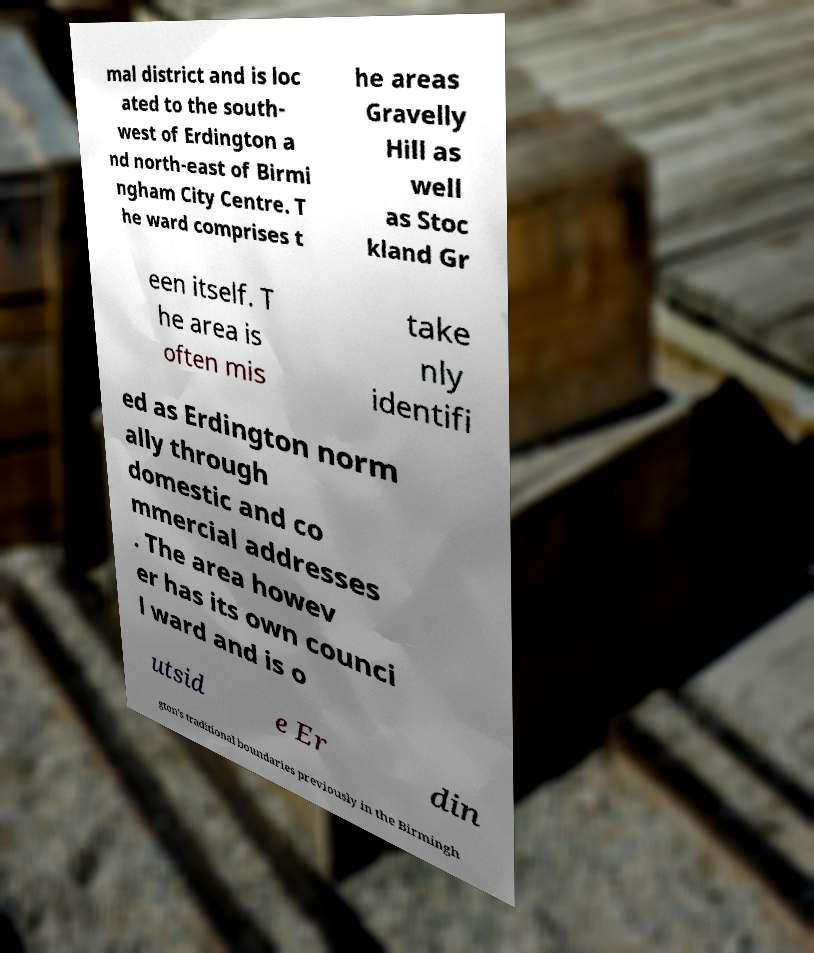Please identify and transcribe the text found in this image. mal district and is loc ated to the south- west of Erdington a nd north-east of Birmi ngham City Centre. T he ward comprises t he areas Gravelly Hill as well as Stoc kland Gr een itself. T he area is often mis take nly identifi ed as Erdington norm ally through domestic and co mmercial addresses . The area howev er has its own counci l ward and is o utsid e Er din gton's traditional boundaries previously in the Birmingh 